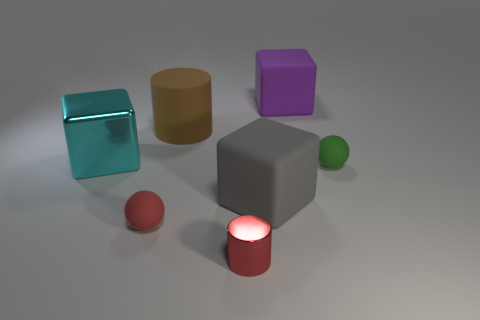Subtract all purple cubes. Subtract all red cylinders. How many cubes are left? 2 Add 3 big cyan cubes. How many objects exist? 10 Subtract all cubes. How many objects are left? 4 Add 2 red rubber blocks. How many red rubber blocks exist? 2 Subtract 0 purple spheres. How many objects are left? 7 Subtract all cyan metal objects. Subtract all small objects. How many objects are left? 3 Add 2 large gray matte objects. How many large gray matte objects are left? 3 